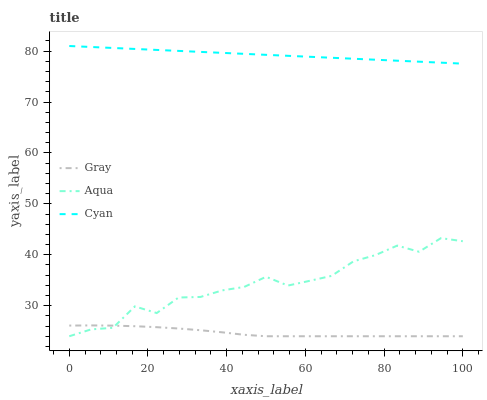Does Gray have the minimum area under the curve?
Answer yes or no. Yes. Does Cyan have the maximum area under the curve?
Answer yes or no. Yes. Does Aqua have the minimum area under the curve?
Answer yes or no. No. Does Aqua have the maximum area under the curve?
Answer yes or no. No. Is Cyan the smoothest?
Answer yes or no. Yes. Is Aqua the roughest?
Answer yes or no. Yes. Is Aqua the smoothest?
Answer yes or no. No. Is Cyan the roughest?
Answer yes or no. No. Does Gray have the lowest value?
Answer yes or no. Yes. Does Cyan have the lowest value?
Answer yes or no. No. Does Cyan have the highest value?
Answer yes or no. Yes. Does Aqua have the highest value?
Answer yes or no. No. Is Gray less than Cyan?
Answer yes or no. Yes. Is Cyan greater than Aqua?
Answer yes or no. Yes. Does Aqua intersect Gray?
Answer yes or no. Yes. Is Aqua less than Gray?
Answer yes or no. No. Is Aqua greater than Gray?
Answer yes or no. No. Does Gray intersect Cyan?
Answer yes or no. No. 